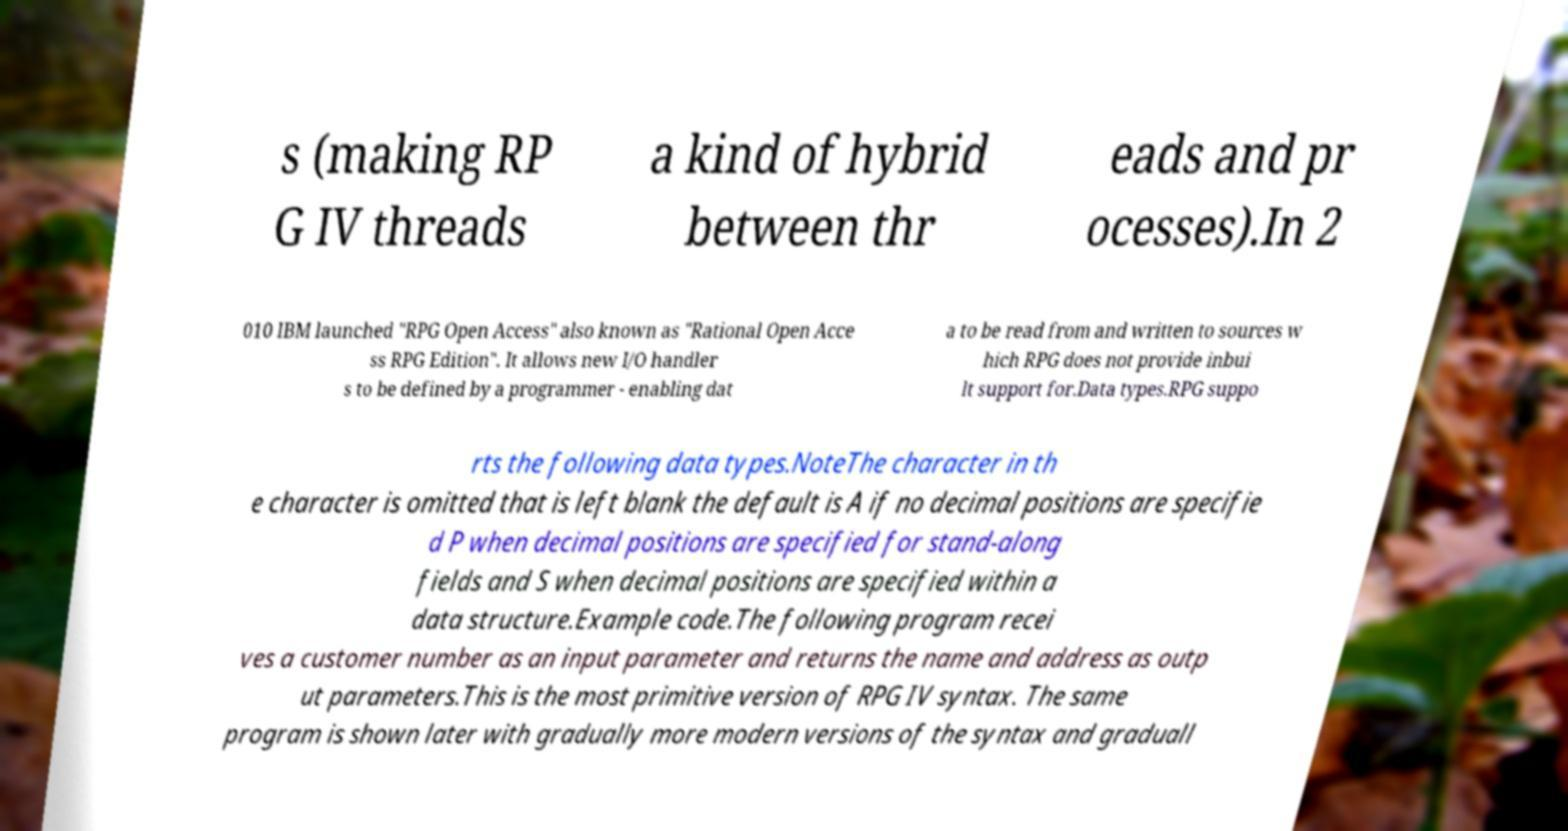Can you accurately transcribe the text from the provided image for me? s (making RP G IV threads a kind of hybrid between thr eads and pr ocesses).In 2 010 IBM launched "RPG Open Access" also known as "Rational Open Acce ss RPG Edition". It allows new I/O handler s to be defined by a programmer - enabling dat a to be read from and written to sources w hich RPG does not provide inbui lt support for.Data types.RPG suppo rts the following data types.NoteThe character in th e character is omitted that is left blank the default is A if no decimal positions are specifie d P when decimal positions are specified for stand-along fields and S when decimal positions are specified within a data structure.Example code.The following program recei ves a customer number as an input parameter and returns the name and address as outp ut parameters.This is the most primitive version of RPG IV syntax. The same program is shown later with gradually more modern versions of the syntax and graduall 